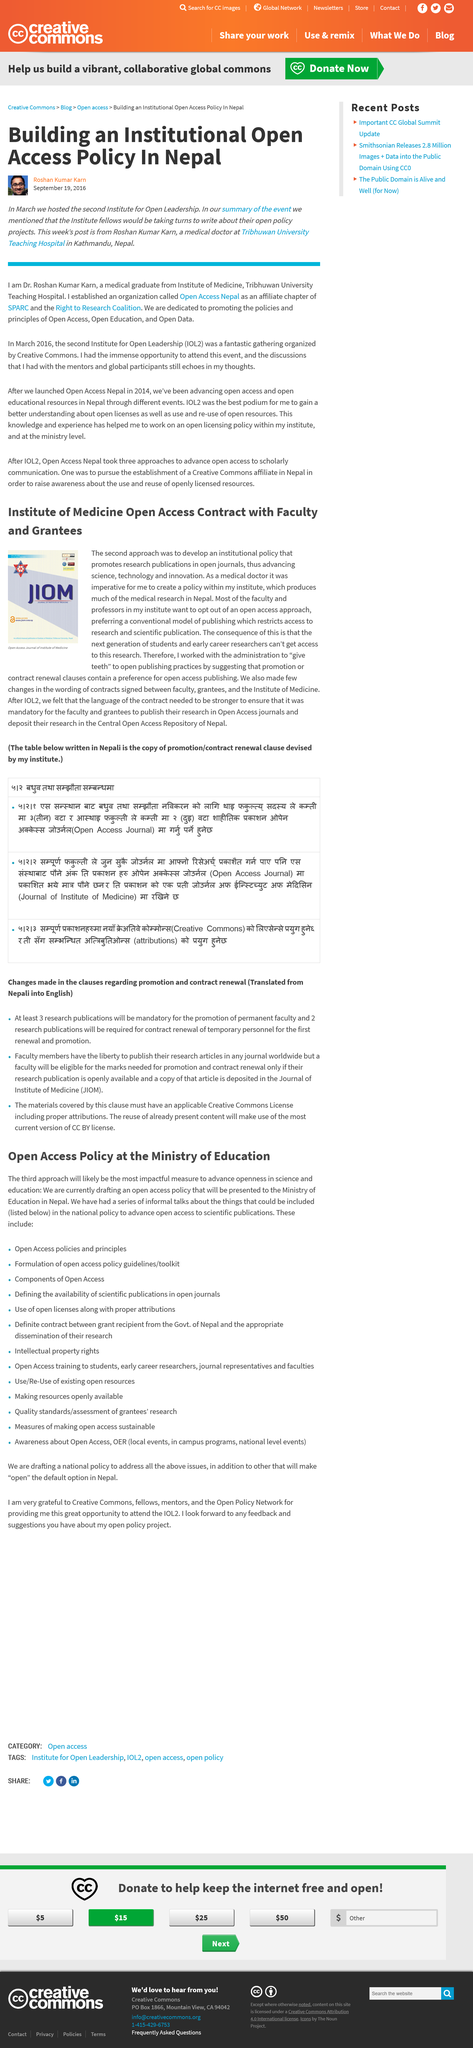Specify some key components in this picture. Roshan Kumar Karn is a medical doctor and recent graduate of Tribhuwan University. An institutional Open Access policy is being built in Nepal. Roshan Kumar Karn established Open Access Nepal, an organization dedicated to promoting open access to information in Nepal. 